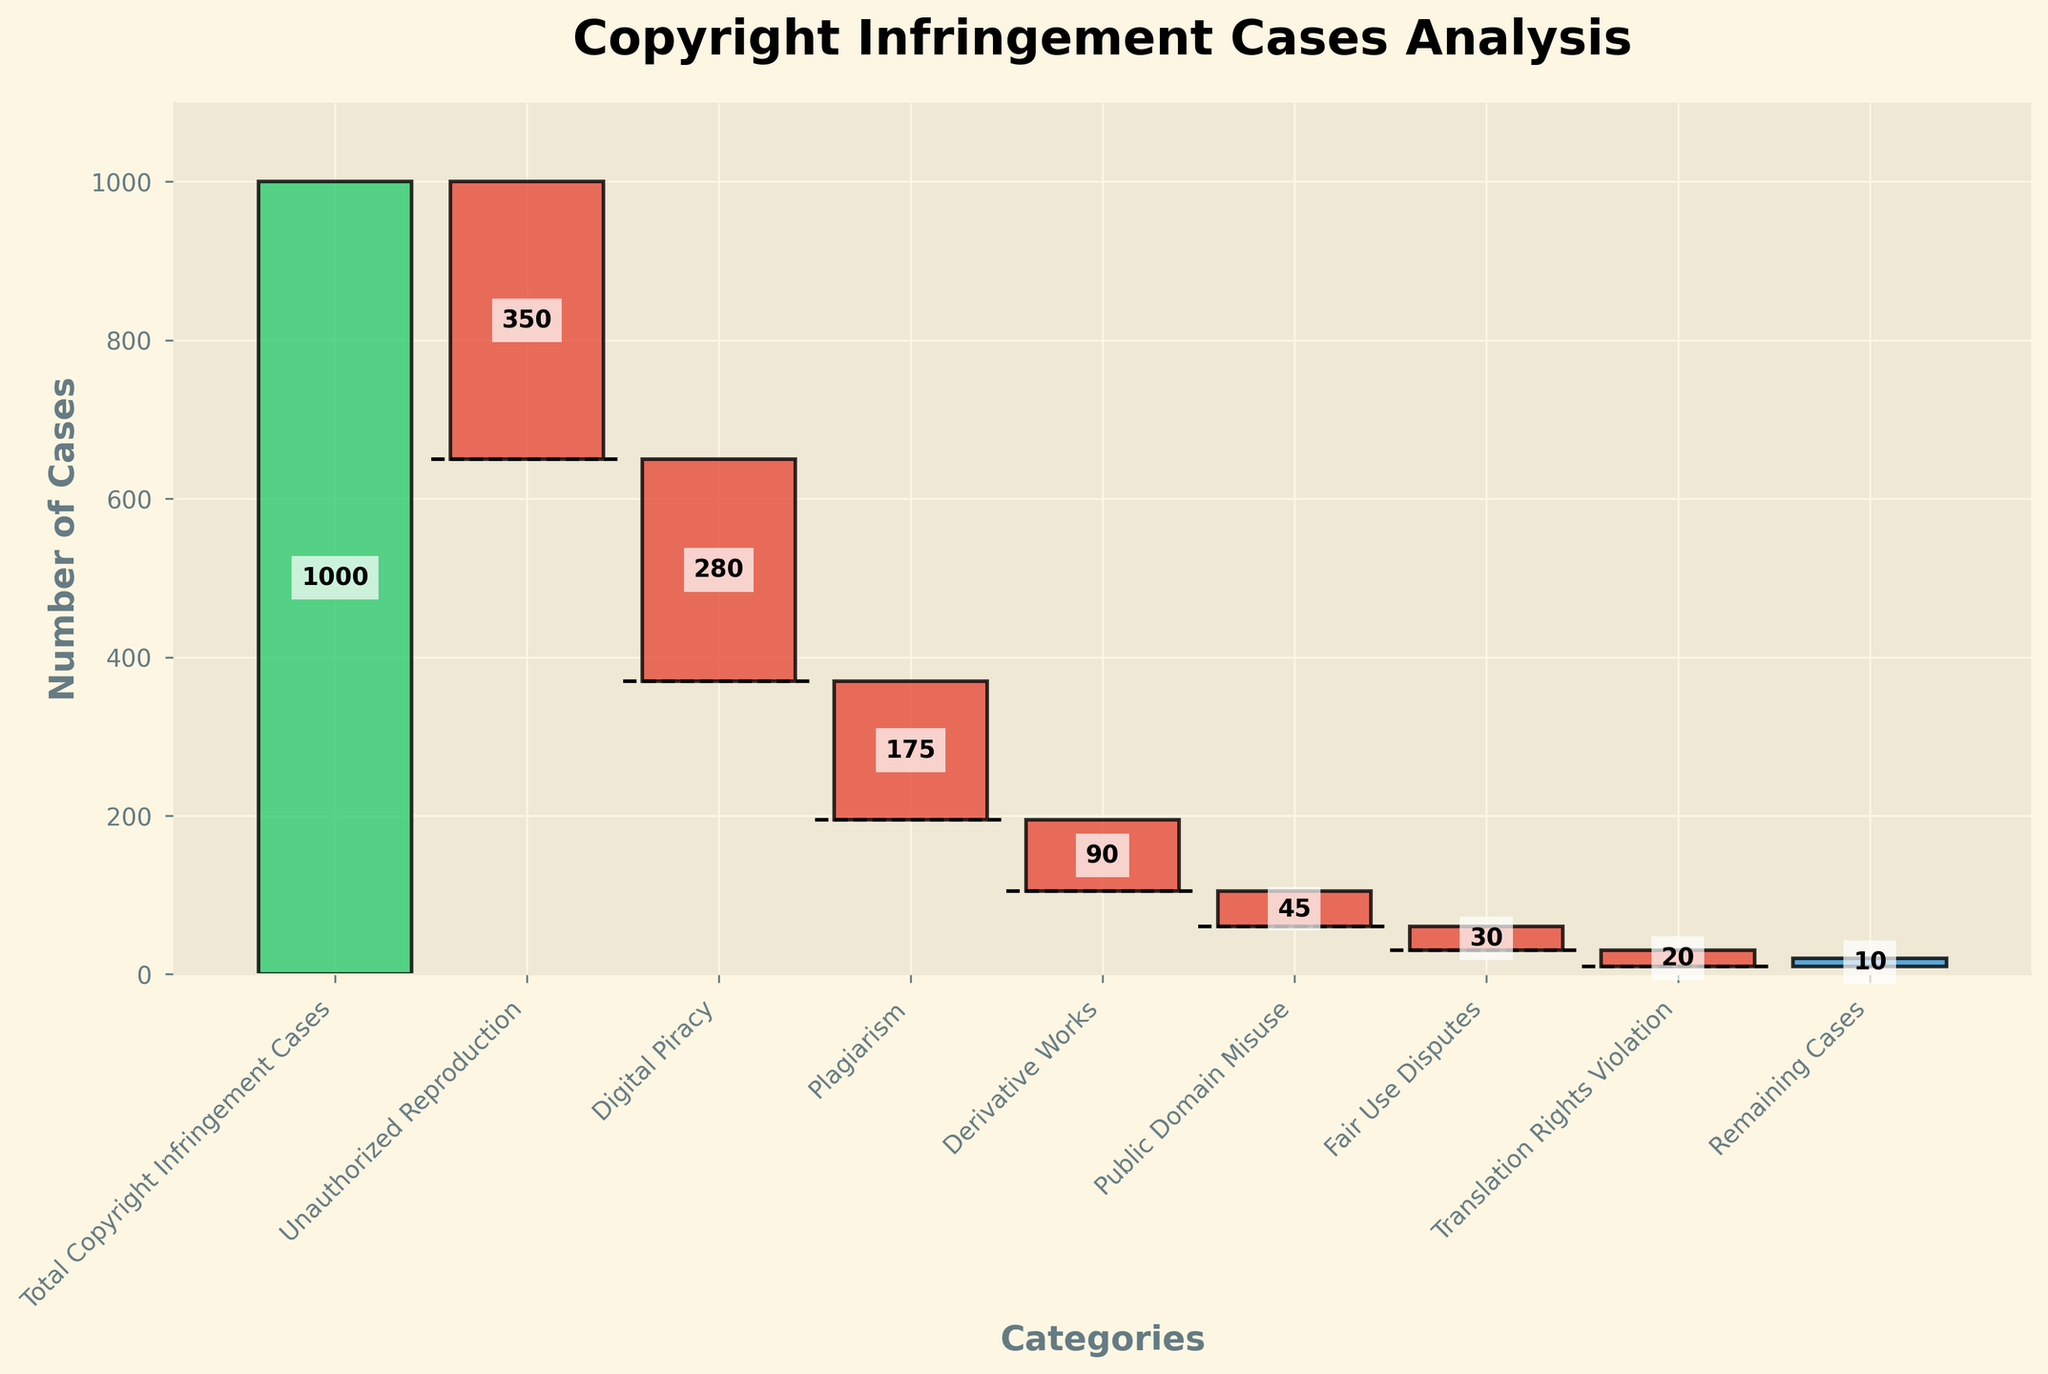What is the title of the figure? The title of a figure is usually found at the top and summarizes the content of the chart. Here, the title clearly describes the chart's purpose.
Answer: Copyright Infringement Cases Analysis What category has the largest negative value? By examining the values of each category, we can see which one has the largest negative number. The bar for Unauthorized Reproduction is the longest and has the largest negative value.
Answer: Unauthorized Reproduction What is the cumulative total for Digital Piracy and Plagiarism? First, identify the bars for Digital Piracy and Plagiarism and their values (-280 and -175 respectively). Then, sum these two values (-280 + -175) to get the cumulative total.
Answer: -455 How many categories have a negative value? All the categories except "Total Copyright Infringement Cases" and "Remaining Cases" are negative. Count these negative categories by inspecting the chart.
Answer: 6 Which is greater, the number of cases for Unauthorized Reproduction or Digital Piracy? Compare the values of Unauthorized Reproduction (-350) and Digital Piracy (-280) by visual inspection. -350 is a larger (more negative) number, making Digital Piracy lesser in infringement cases.
Answer: Unauthorized Reproduction What is the value for Remaining Cases? Identify the bar labeled "Remaining Cases" and note its value directly.
Answer: 10 What is the total for Unauthorized Reproduction, Digital Piracy, and Plagiarism combined? Sum the values for Unauthorized Reproduction (-350), Digital Piracy (-280), and Plagiarism (-175) by adding them together. -350 + -280 + -175 = -805.
Answer: -805 Does the value for Fair Use Disputes fall within the top three most frequent types of violations? Compare the value for Fair Use Disputes (-30) against all categories. The top three most frequent violations are Unauthorized Reproduction, Digital Piracy, and Plagiarism. Since -30 is much less negative, it does not fall into the top three.
Answer: No Which category other than "Remaining Cases" and "Total Copyright Infringement Cases" has the smallest negative value? Compare the remaining negative categories to find the smallest one: Derivative Works (-90), Public Domain Misuse (-45), Fair Use Disputes (-30), Translation Rights Violation (-20), and choose the closest to zero.
Answer: Translation Rights Violation 